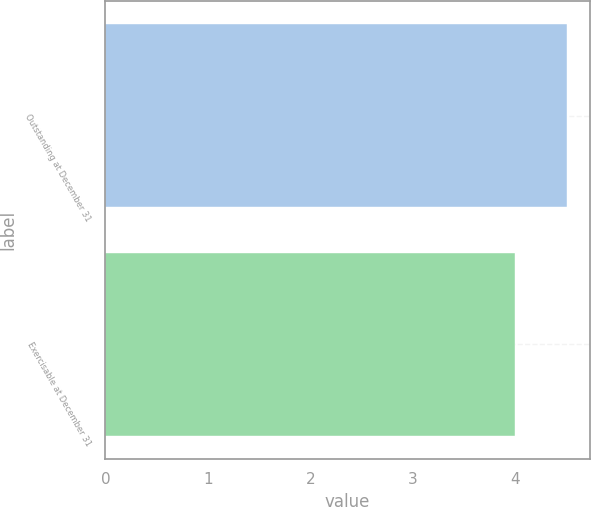Convert chart. <chart><loc_0><loc_0><loc_500><loc_500><bar_chart><fcel>Outstanding at December 31<fcel>Exercisable at December 31<nl><fcel>4.5<fcel>4<nl></chart> 